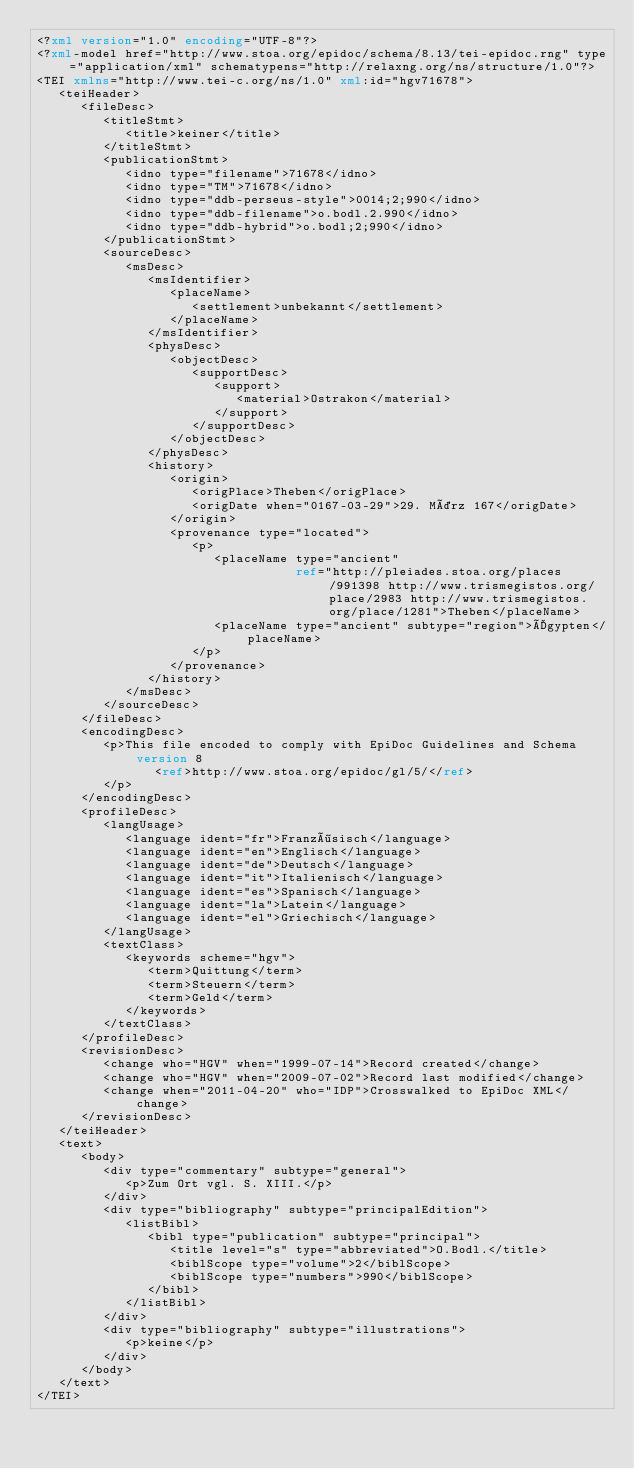<code> <loc_0><loc_0><loc_500><loc_500><_XML_><?xml version="1.0" encoding="UTF-8"?>
<?xml-model href="http://www.stoa.org/epidoc/schema/8.13/tei-epidoc.rng" type="application/xml" schematypens="http://relaxng.org/ns/structure/1.0"?>
<TEI xmlns="http://www.tei-c.org/ns/1.0" xml:id="hgv71678">
   <teiHeader>
      <fileDesc>
         <titleStmt>
            <title>keiner</title>
         </titleStmt>
         <publicationStmt>
            <idno type="filename">71678</idno>
            <idno type="TM">71678</idno>
            <idno type="ddb-perseus-style">0014;2;990</idno>
            <idno type="ddb-filename">o.bodl.2.990</idno>
            <idno type="ddb-hybrid">o.bodl;2;990</idno>
         </publicationStmt>
         <sourceDesc>
            <msDesc>
               <msIdentifier>
                  <placeName>
                     <settlement>unbekannt</settlement>
                  </placeName>
               </msIdentifier>
               <physDesc>
                  <objectDesc>
                     <supportDesc>
                        <support>
                           <material>Ostrakon</material>
                        </support>
                     </supportDesc>
                  </objectDesc>
               </physDesc>
               <history>
                  <origin>
                     <origPlace>Theben</origPlace>
                     <origDate when="0167-03-29">29. März 167</origDate>
                  </origin>
                  <provenance type="located">
                     <p>
                        <placeName type="ancient"
                                   ref="http://pleiades.stoa.org/places/991398 http://www.trismegistos.org/place/2983 http://www.trismegistos.org/place/1281">Theben</placeName>
                        <placeName type="ancient" subtype="region">Ägypten</placeName>
                     </p>
                  </provenance>
               </history>
            </msDesc>
         </sourceDesc>
      </fileDesc>
      <encodingDesc>
         <p>This file encoded to comply with EpiDoc Guidelines and Schema version 8
                <ref>http://www.stoa.org/epidoc/gl/5/</ref>
         </p>
      </encodingDesc>
      <profileDesc>
         <langUsage>
            <language ident="fr">Französisch</language>
            <language ident="en">Englisch</language>
            <language ident="de">Deutsch</language>
            <language ident="it">Italienisch</language>
            <language ident="es">Spanisch</language>
            <language ident="la">Latein</language>
            <language ident="el">Griechisch</language>
         </langUsage>
         <textClass>
            <keywords scheme="hgv">
               <term>Quittung</term>
               <term>Steuern</term>
               <term>Geld</term>
            </keywords>
         </textClass>
      </profileDesc>
      <revisionDesc>
         <change who="HGV" when="1999-07-14">Record created</change>
         <change who="HGV" when="2009-07-02">Record last modified</change>
         <change when="2011-04-20" who="IDP">Crosswalked to EpiDoc XML</change>
      </revisionDesc>
   </teiHeader>
   <text>
      <body>
         <div type="commentary" subtype="general">
            <p>Zum Ort vgl. S. XIII.</p>
         </div>
         <div type="bibliography" subtype="principalEdition">
            <listBibl>
               <bibl type="publication" subtype="principal">
                  <title level="s" type="abbreviated">O.Bodl.</title>
                  <biblScope type="volume">2</biblScope>
                  <biblScope type="numbers">990</biblScope>
               </bibl>
            </listBibl>
         </div>
         <div type="bibliography" subtype="illustrations">
            <p>keine</p>
         </div>
      </body>
   </text>
</TEI>
</code> 